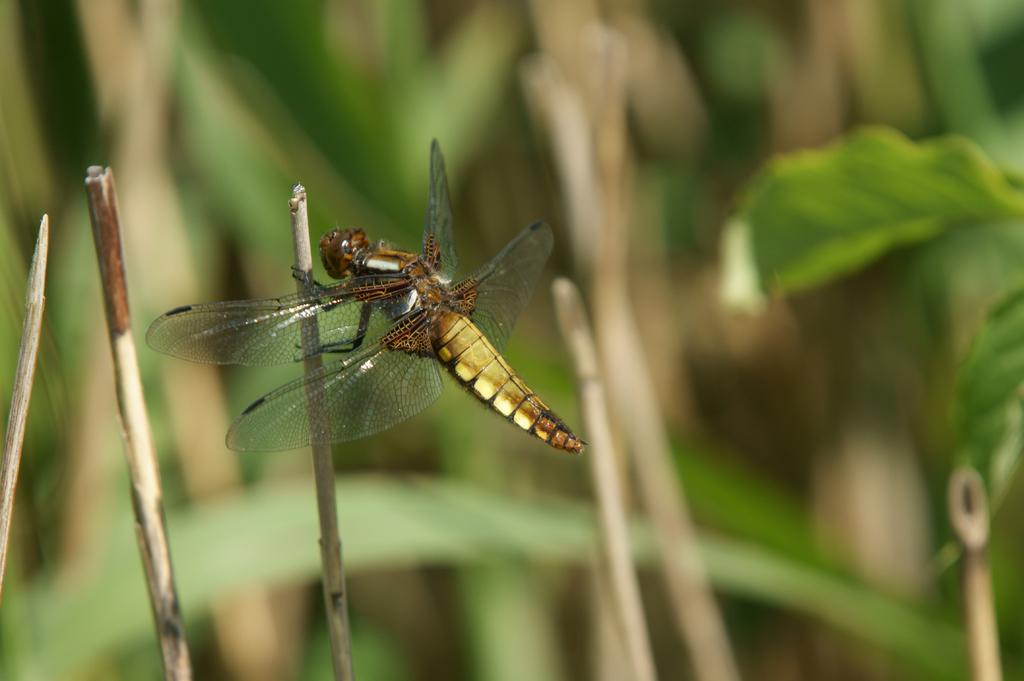What insect is present in the image? There is a dragonfly in the image. Can you describe the background of the image? The background of the image is blurred. How many cherries are hanging from the dragonfly's wings in the image? There are no cherries present in the image, and they are not hanging from the dragonfly's wings. 